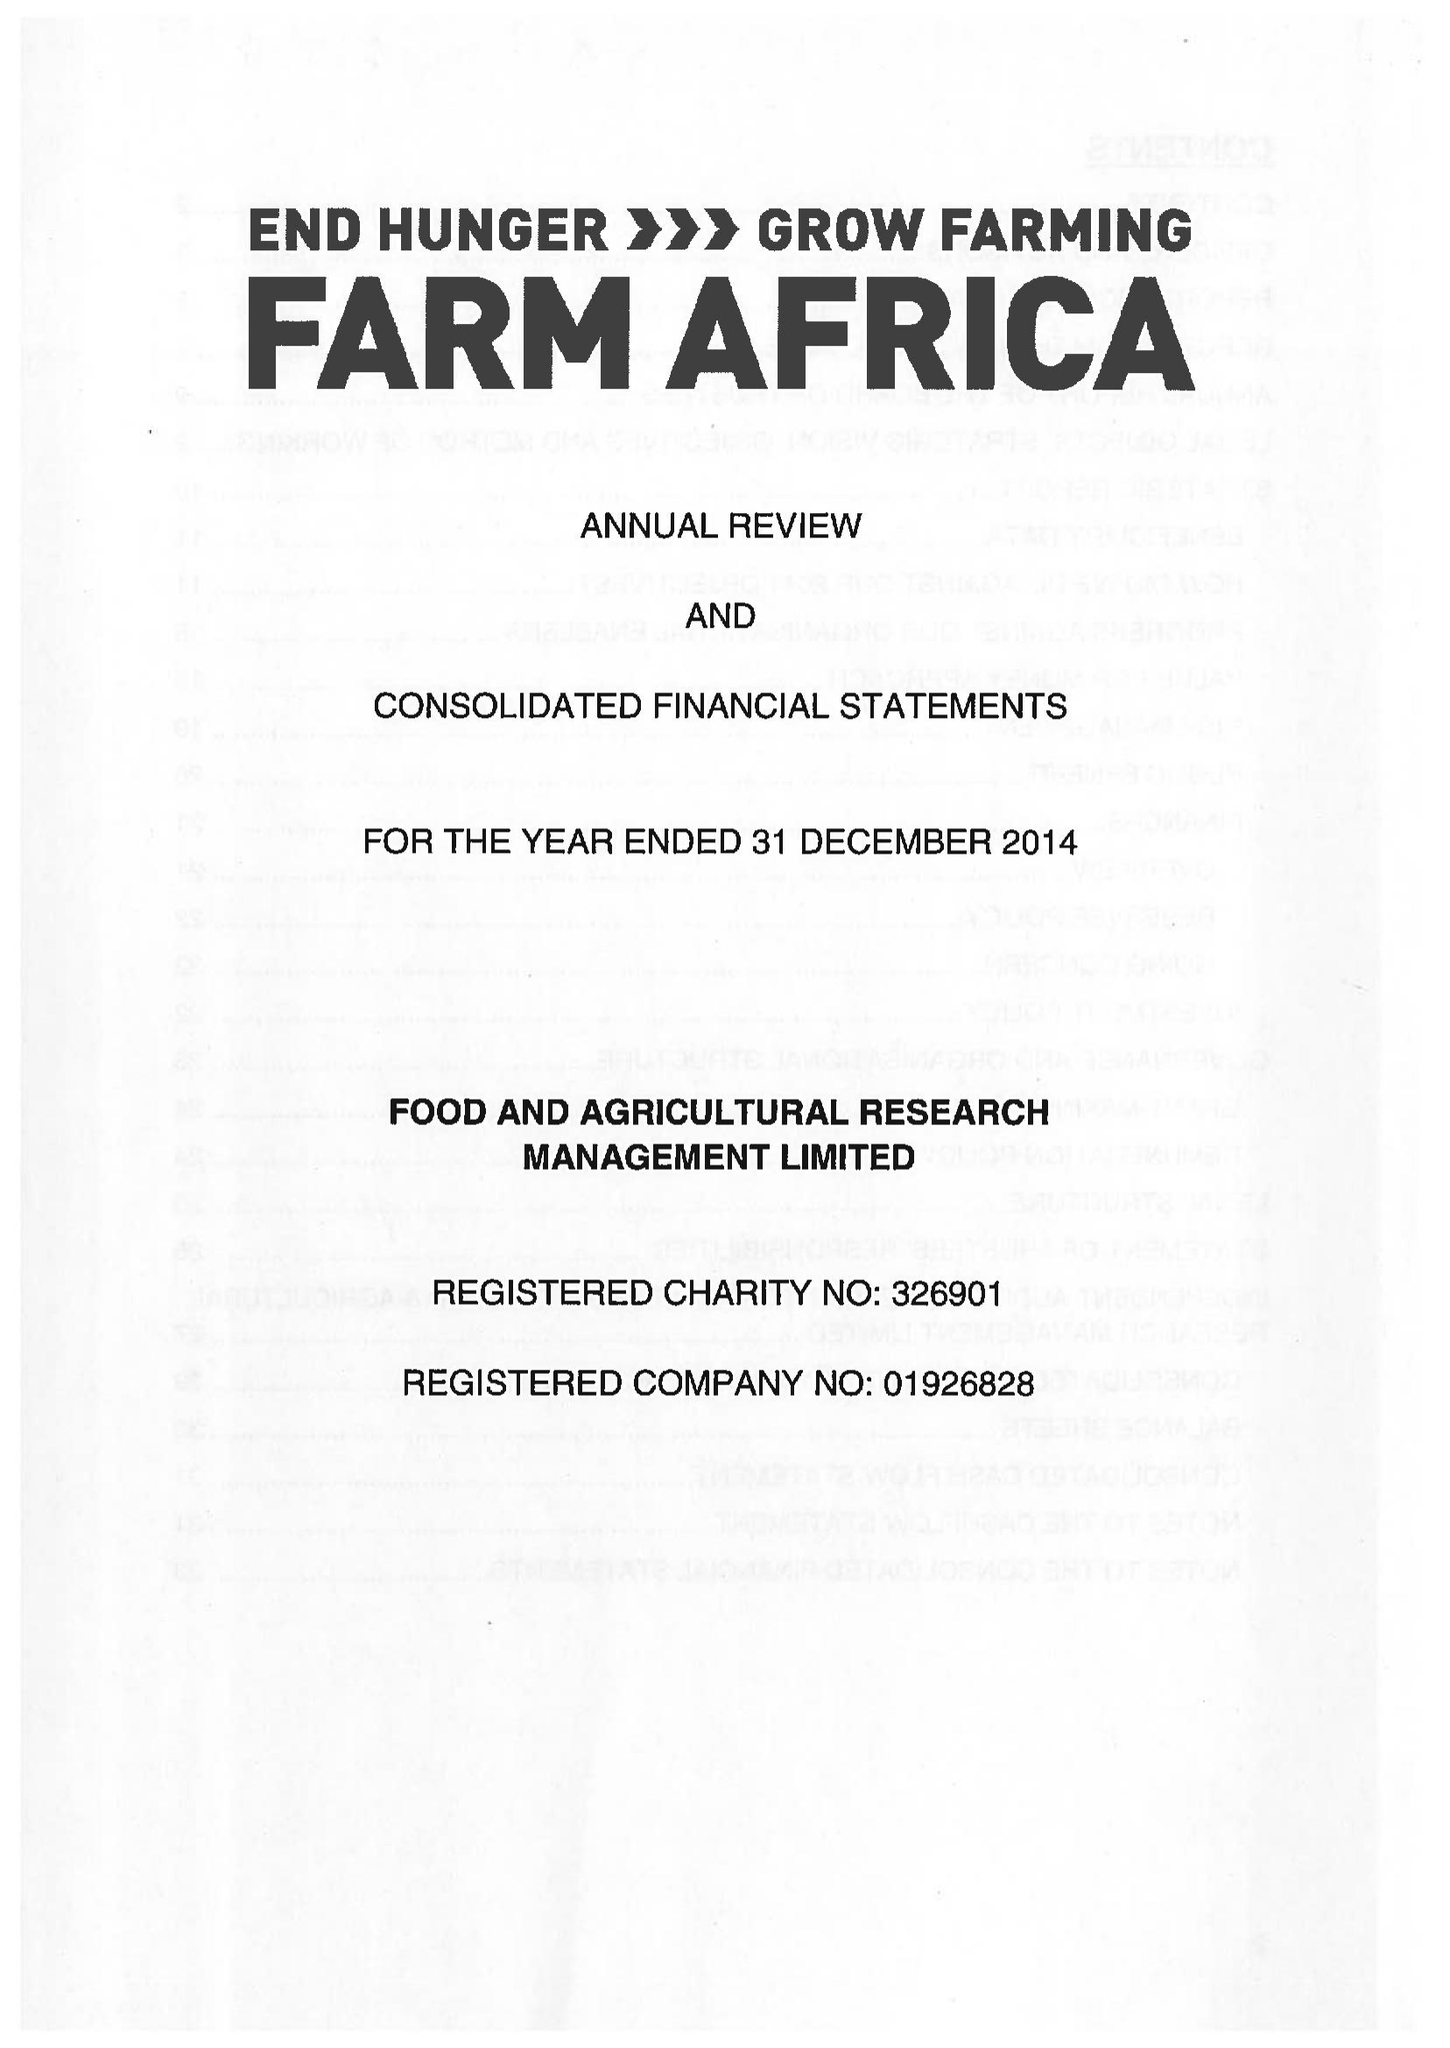What is the value for the address__post_town?
Answer the question using a single word or phrase. LONDON 